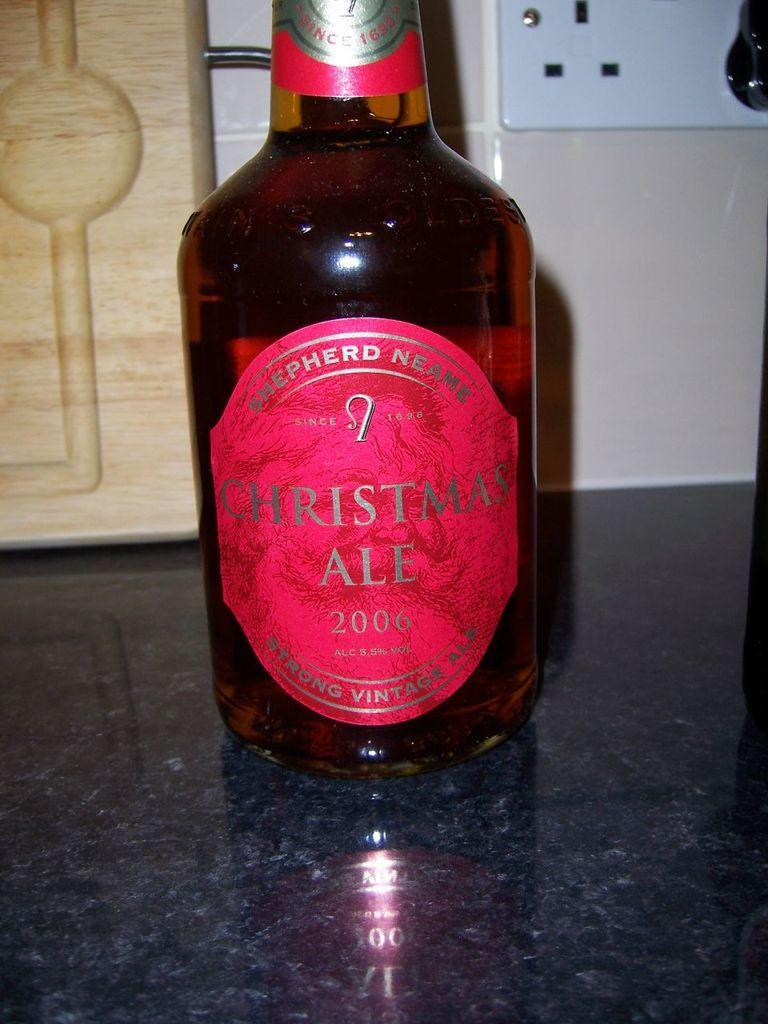<image>
Share a concise interpretation of the image provided. a Christmas ale bottle on the table that is black 